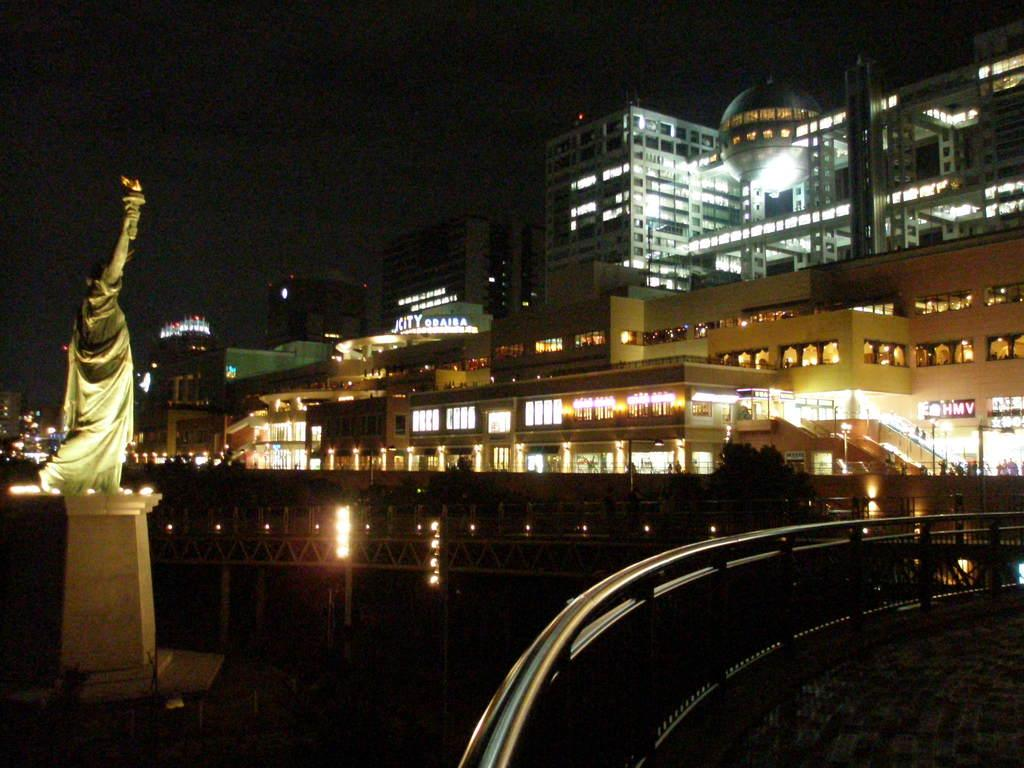What is the overall lighting condition in the image? The image is dark. What can be seen on the bridge in the image? There is a railing on the bridge in the image. What type of structure is present in the image? There is a bridge in the image, as well as buildings. What is the source of light in the image? There are lights in the image. What additional feature can be found in the image? There is a statue in the image. What type of writing can be seen on the hall in the image? There is no hall present in the image, so no writing can be observed. 